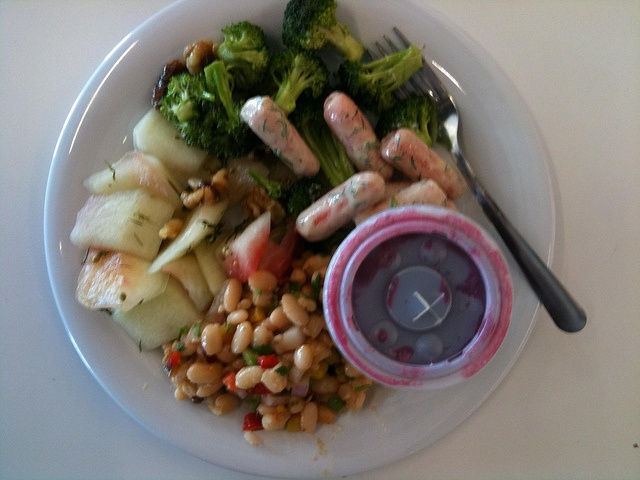Describe the objects in this image and their specific colors. I can see broccoli in darkgray, black, olive, gray, and darkgreen tones, broccoli in darkgray, black, darkgreen, and gray tones, fork in darkgray, black, gray, and darkgreen tones, carrot in darkgray, gray, and maroon tones, and carrot in darkgray, gray, brown, and black tones in this image. 